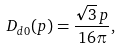Convert formula to latex. <formula><loc_0><loc_0><loc_500><loc_500>D _ { d 0 } ( p ) = \frac { \sqrt { 3 } \, p } { 1 6 \pi } ,</formula> 